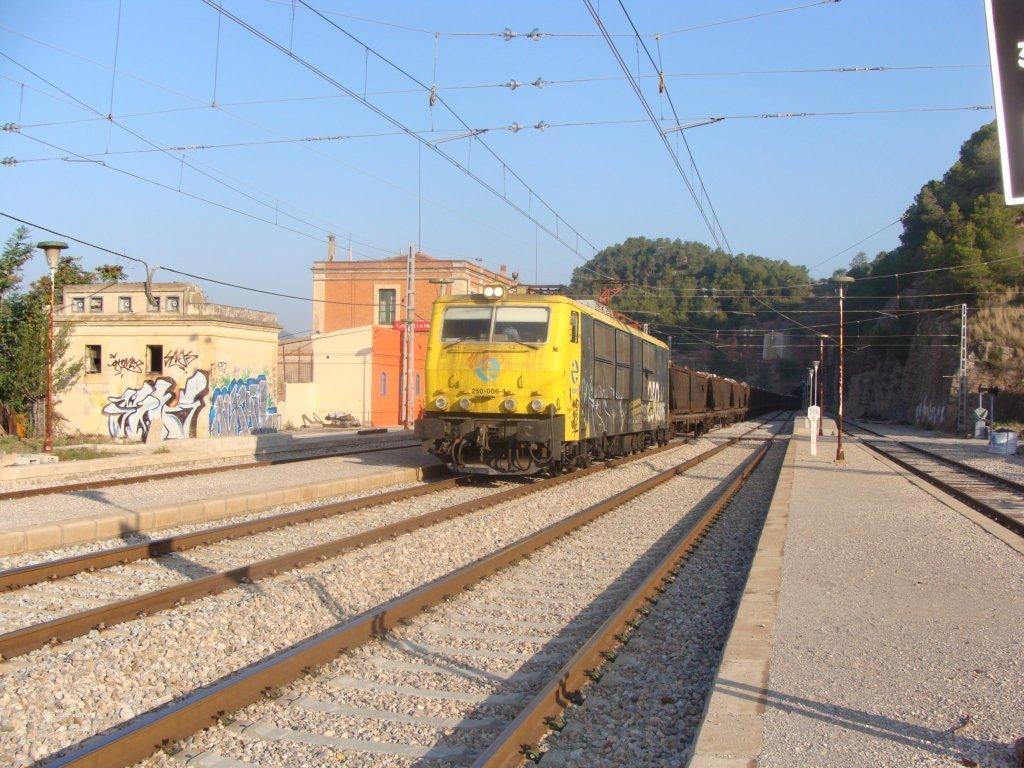Could you give a brief overview of what you see in this image? In this image I can see a train on the railway track. It is in yellow,black and brown color. Back I can see a buildings,windows and poles. I can see wires and trees. The sky is in blue color. 